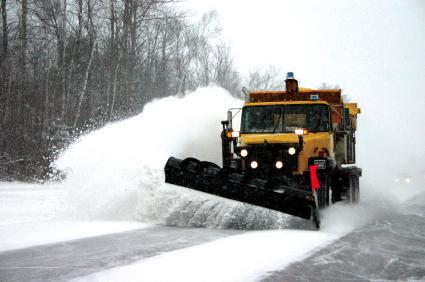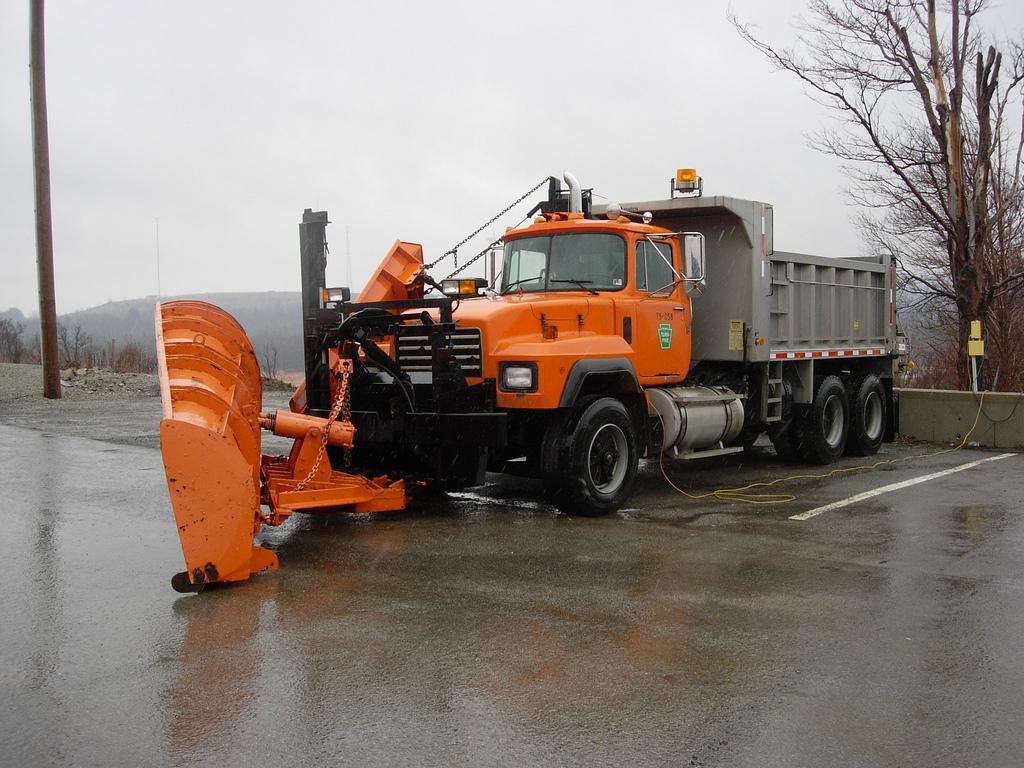The first image is the image on the left, the second image is the image on the right. Given the left and right images, does the statement "In one of the images, the snow plow is not pushing snow." hold true? Answer yes or no. Yes. 